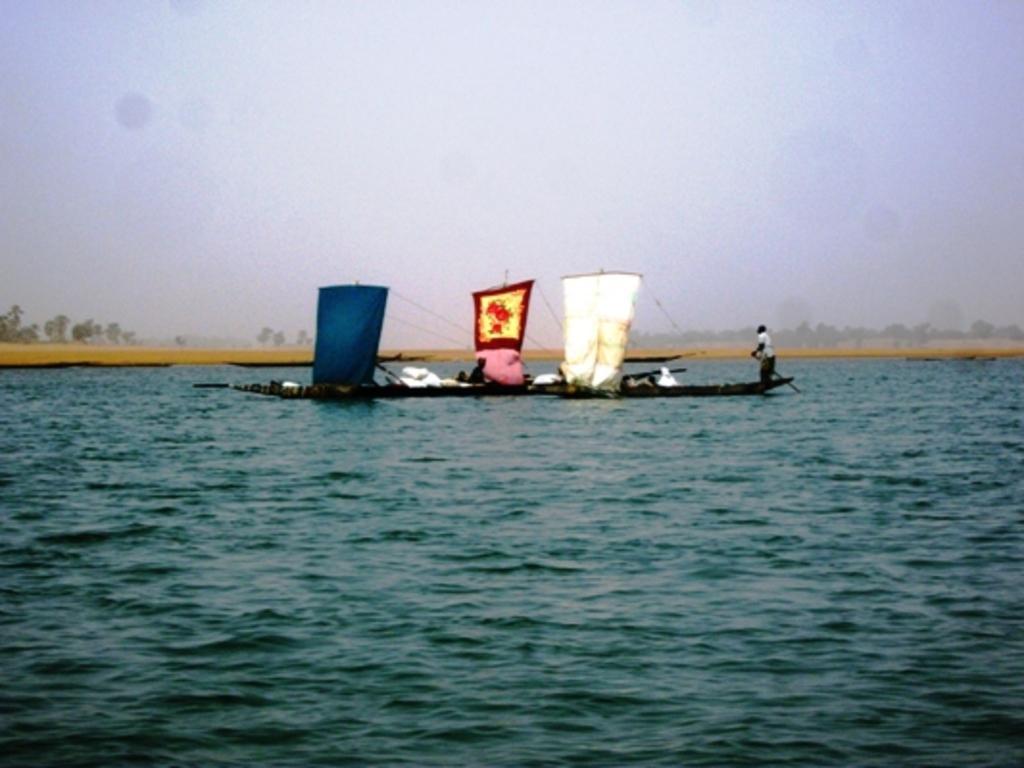Please provide a concise description of this image. In the center of the image, we can see people on the boats and at the bottom, there is water. 